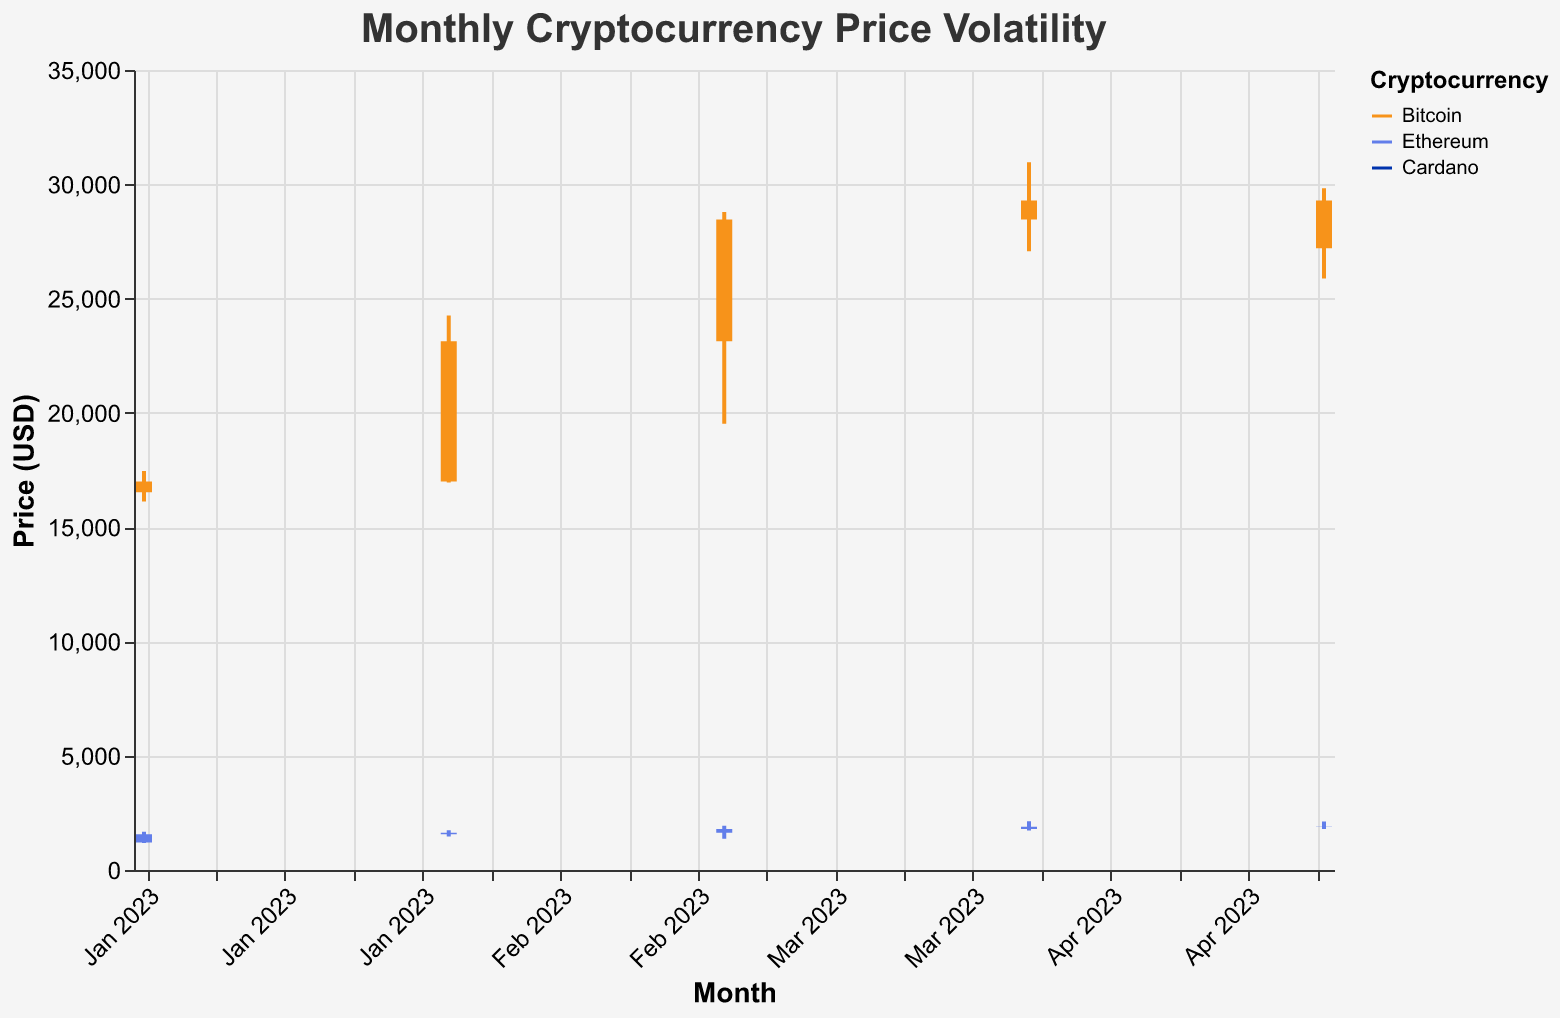Which month had the highest price for Bitcoin? The highest high for Bitcoin can be observed by scanning the "High" values for each month. In March 2023, the highest price was 28789.12.
Answer: March 2023 What was the price range (difference between high and low) for Ethereum in April 2023? Identify the high and low prices for Ethereum in April 2023. The high was 2137.56 and the low was 1723.45. Subtract the low from the high: 2137.56 - 1723.45 = 414.11.
Answer: 414.11 Which cryptocurrency had the highest volatility in May 2023? Volatility can be inferred from the price range (High - Low). Comparing the price ranges for Bitcoin, Ethereum, and Cardano in May 2023: Bitcoin: 29823.56 - 25879.12 = 3944.44, Ethereum: 2123.45 - 1789.23 = 334.22, and Cardano: 0.4123 - 0.3456 = 0.0667. Bitcoin has the highest volatility.
Answer: Bitcoin How did the closing price of Cardano change from February to March 2023? The closing price of Cardano in February 2023 was 0.3589, and in March 2023 it was 0.3890. The change can be calculated by subtracting the February closing price from the March closing price: 0.3890 - 0.3589 = 0.0301.
Answer: +0.0301 Which month showed the highest increase in closing price for Bitcoin from the previous month? Compare the differences between closing prices for adjacent months: Jan-Feb: 23134.56 - 16993.74 = 6140.82, Feb-Mar: 28458.67 - 23134.56 = 5324.11, Mar-Apr: 29288.91 - 28458.67 = 830.24, Apr-May: 27198.45 - 29288.91 = -2090.46. The highest increase is from January to February (6140.82).
Answer: February 2023 Did Ethereum's closing price increase or decrease from April 2023 to May 2023? Ethereum's closing price in April 2023 was 1890.78 and in May 2023 it was 1876.90. Comparing the numbers: 1876.90 < 1890.78, so it decreased.
Answer: Decreased By how much did the opening price of Bitcoin change from March to April 2023? The opening price of Bitcoin in March 2023 was 23134.56, and in April 2023 it was 28458.67. The change can be calculated as: 28458.67 - 23134.56 = 5324.11.
Answer: +5324.11 Which cryptocurrency had the lowest closing price among all months? Looking at the lowest closing prices across all months and cryptocurrencies: Bitcoin (February: 23134.56), Ethereum (January: 1567.34), Cardano (February: 0.3589). The lowest value is Cardano in February at 0.3589.
Answer: Cardano Was there any month where Ethereum's opening and closing prices were the same? By comparing the opening and closing prices of Ethereum for each month: January (1197.89 ≠ 1567.34), February (1567.34 ≠ 1634.56), March (1634.56 ≠ 1789.12), April (1789.12 ≠ 1890.78), May (1890.78 ≠ 1876.90). No month had the same opening and closing prices.
Answer: No What was the highest closing price for Cardano in 2023? Identify the highest closing price for Cardano from the data: January (0.3756), February (0.3589), March (0.3890), April (0.3978), May (0.3789). The highest value is in April 2023: 0.3978.
Answer: 0.3978 